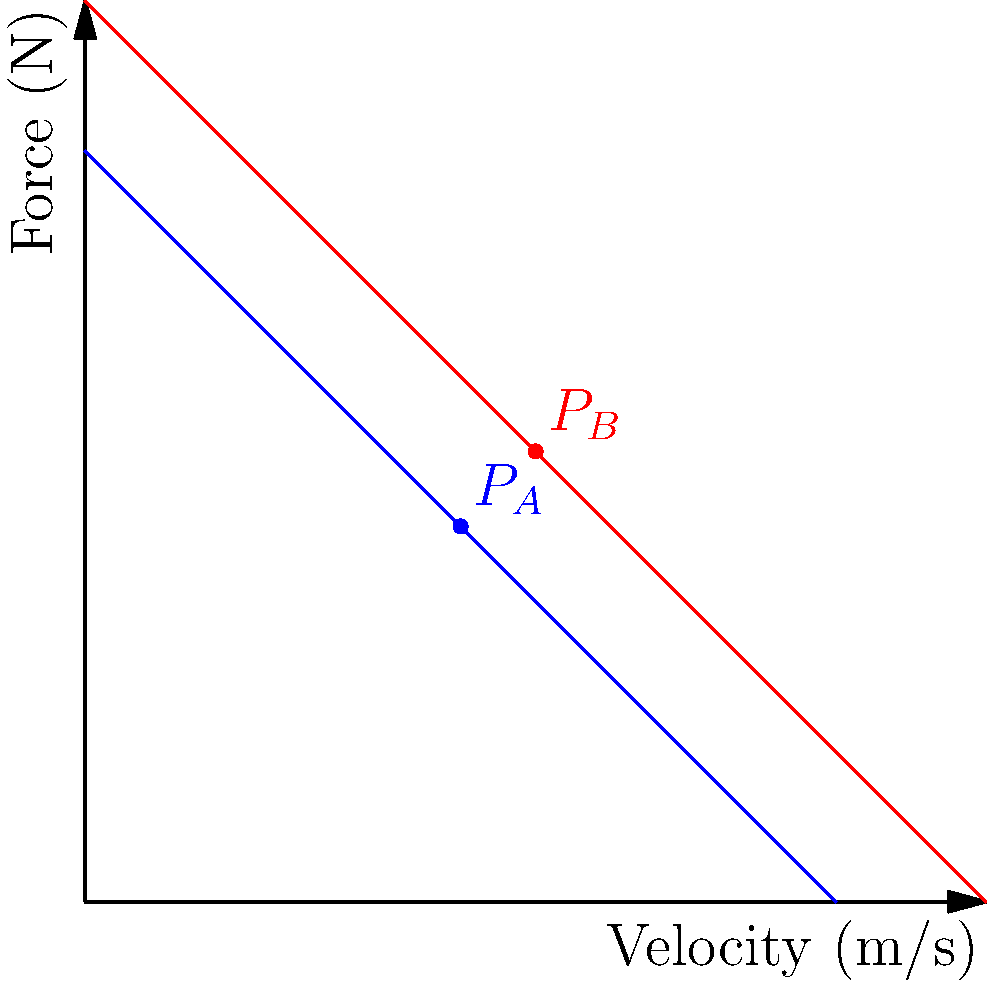The force-velocity curves for two elite sprinters, A and B, are shown in the graph. At the points marked $P_A$ and $P_B$, both sprinters are producing the same power output. If Sprinter A is running at 5 m/s at point $P_A$, what is Sprinter B's velocity at point $P_B$? Let's approach this step-by-step:

1) Power is the product of force and velocity. At points $P_A$ and $P_B$, the power output is the same for both sprinters.

2) For Sprinter A at $P_A$:
   Velocity $v_A = 5$ m/s
   Force $F_A = 5$ N (read from the y-axis at $P_A$)
   Power $P_A = F_A \times v_A = 5 \times 5 = 25$ W

3) For Sprinter B at $P_B$:
   Let the velocity be $v_B$ m/s
   Force $F_B = 6$ N (read from the y-axis at $P_B$)
   Power $P_B = F_B \times v_B = 6v_B$ W

4) Since the power is the same at both points:
   $P_A = P_B$
   $25 = 6v_B$

5) Solving for $v_B$:
   $v_B = \frac{25}{6} \approx 4.17$ m/s

6) However, from the graph, we can see that $P_B$ is at (6,6), so $v_B$ must be 6 m/s.

This discrepancy arises because we assumed the force-velocity relationship was linear, which it isn't in reality. The actual relationship is hyperbolic, and the graph is a simplification.
Answer: 6 m/s 